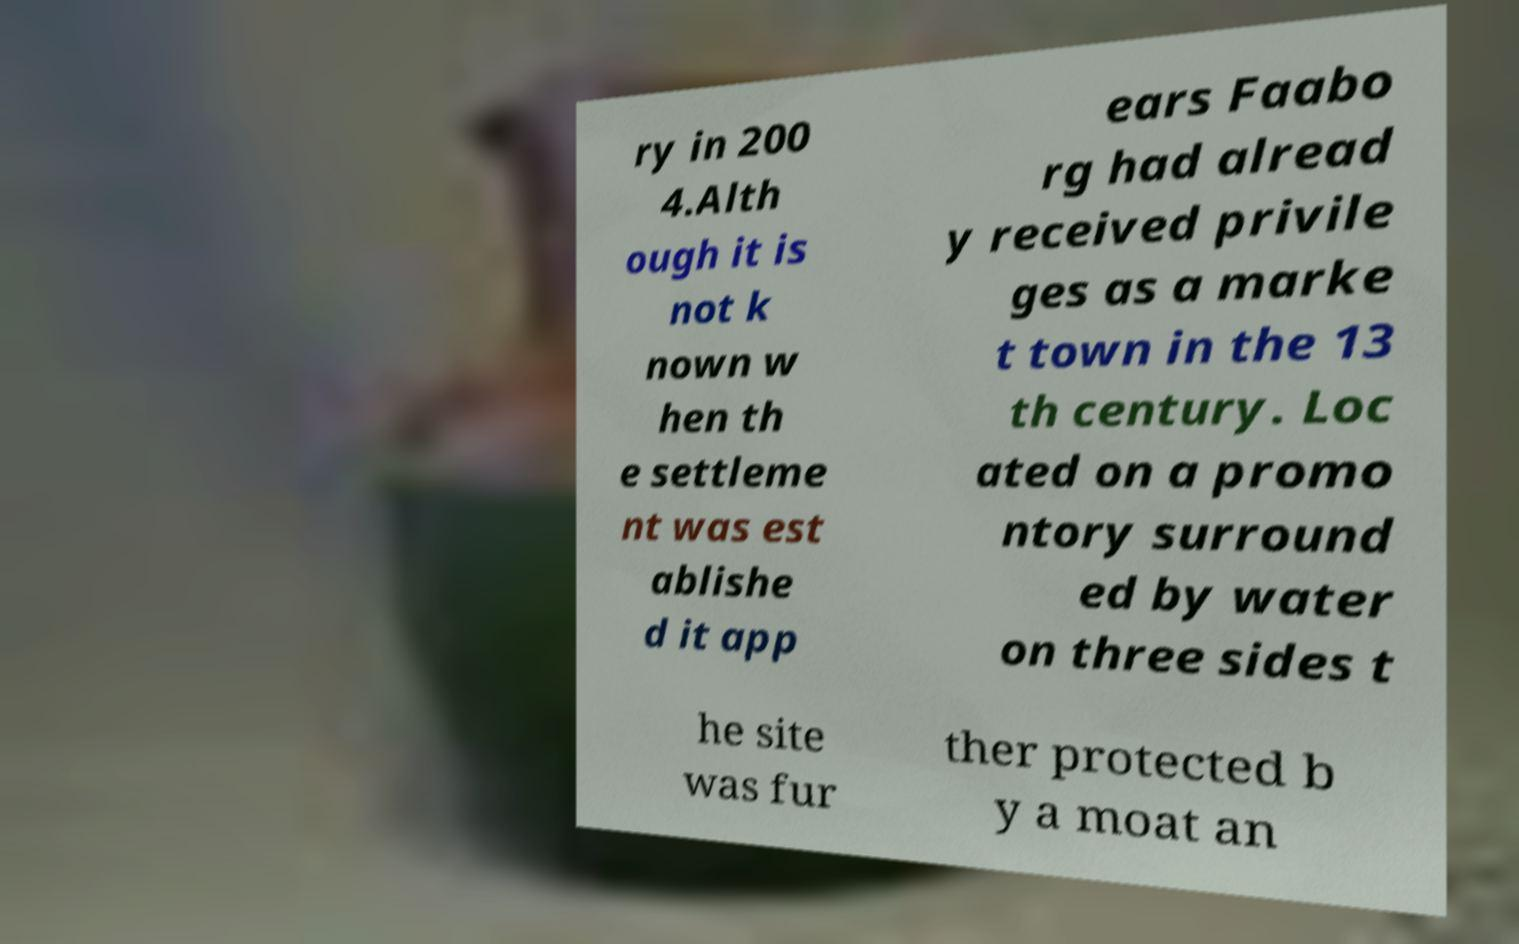Could you assist in decoding the text presented in this image and type it out clearly? ry in 200 4.Alth ough it is not k nown w hen th e settleme nt was est ablishe d it app ears Faabo rg had alread y received privile ges as a marke t town in the 13 th century. Loc ated on a promo ntory surround ed by water on three sides t he site was fur ther protected b y a moat an 